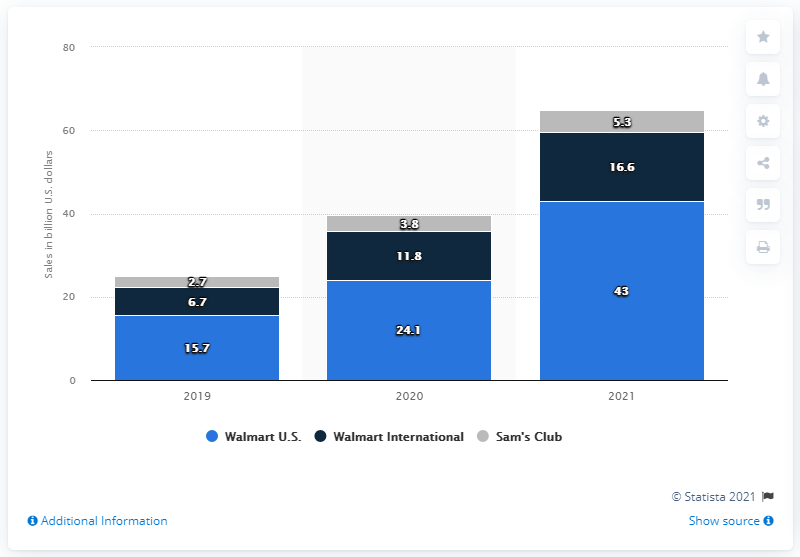Highlight a few significant elements in this photo. In 2021, Walmart's eCommerce sales were $43 billion. 